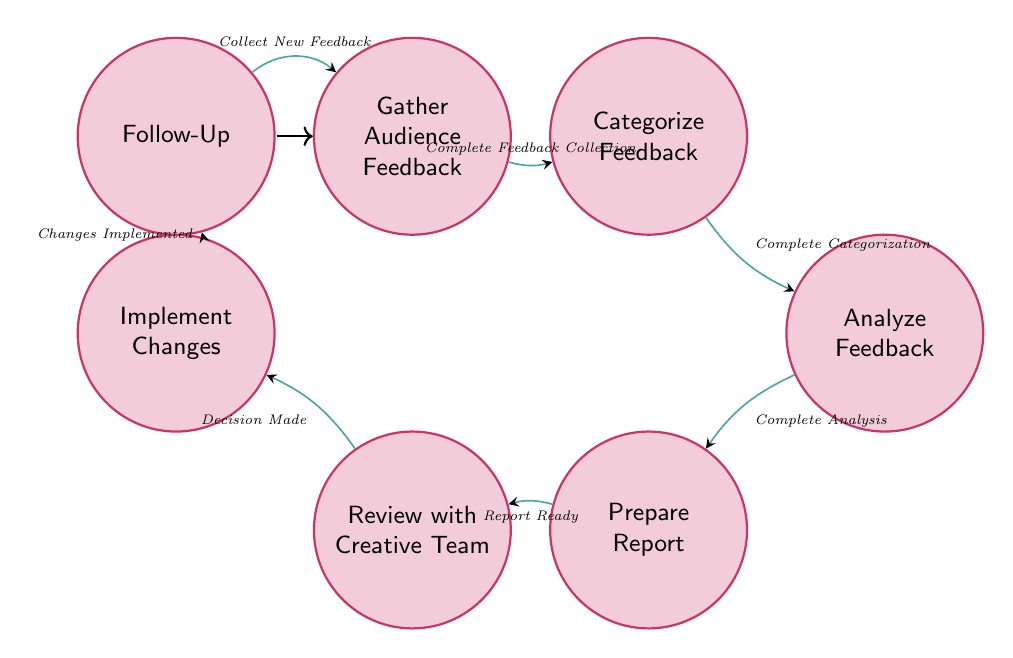What is the initial state of the diagram? The initial state in the diagram is labeled "Gather Audience Feedback." It is marked with an initial indicator, which shows where the flow begins.
Answer: Gather Audience Feedback How many states are in the diagram? To find the number of states, we can count each unique state node listed in the diagram. There are seven distinct states.
Answer: Seven What action transitions from "Review with Creative Team" to "Implement Changes"? By looking at the transition arrows, the action listed between these two states is "Decision Made." This indicates what action prompts the shift from reviewing the feedback to implementing changes.
Answer: Decision Made Which state comes after "Analyze Feedback"? The diagram shows a direct transition from "Analyze Feedback" to "Prepare Report" with the corresponding action "Complete Analysis." This indicates the next step in the sequence following analysis.
Answer: Prepare Report What is the last state in the feedback processing flow? The feedback processing flow ends at "Follow-Up," which is the final state before the process returns to "Gather Audience Feedback." We recognize it as the last step before the cycle repeats.
Answer: Follow-Up What actions are required to move from "Gather Audience Feedback" to "Analyze Feedback"? The flow requires two actions: first, "Complete Feedback Collection" to move to "Categorize Feedback," and then "Complete Categorization" to transition into "Analyze Feedback." Both steps are necessary to prepare the feedback for analysis.
Answer: Two actions How does the state "Implement Changes" relate to "Follow-Up"? The connection between "Implement Changes" and "Follow-Up" is established by the action "Changes Implemented," indicating that following the implementation of changes, the next step is to monitor and gather new feedback.
Answer: Changes Implemented Which state requires a report to be ready before moving onto the next? The "Prepare Report" state requires the action "Report Ready" to transition into the "Review with Creative Team" state, highlighting the importance of the report before discussing feedback with the creative team.
Answer: Prepare Report What is the main purpose of the "Analyze Feedback" state? The "Analyze Feedback" state primarily focuses on reviewing and analyzing feedback, specifically looking for recurring themes and detailed observations, making it a critical part of the feedback processing.
Answer: Review and analyze feedback 